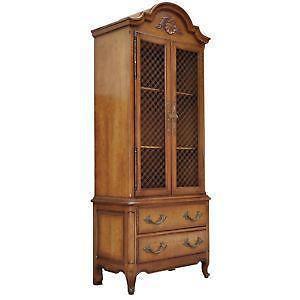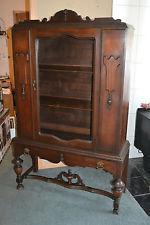The first image is the image on the left, the second image is the image on the right. Considering the images on both sides, is "All the cabinets have legs." valid? Answer yes or no. Yes. 